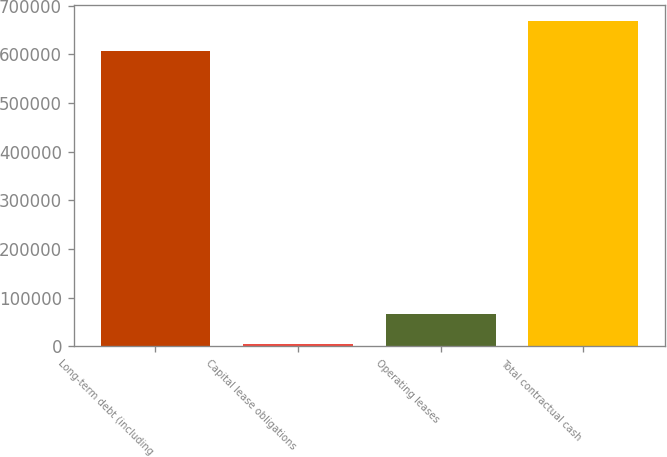Convert chart. <chart><loc_0><loc_0><loc_500><loc_500><bar_chart><fcel>Long-term debt (including<fcel>Capital lease obligations<fcel>Operating leases<fcel>Total contractual cash<nl><fcel>607154<fcel>4602<fcel>65834<fcel>668386<nl></chart> 